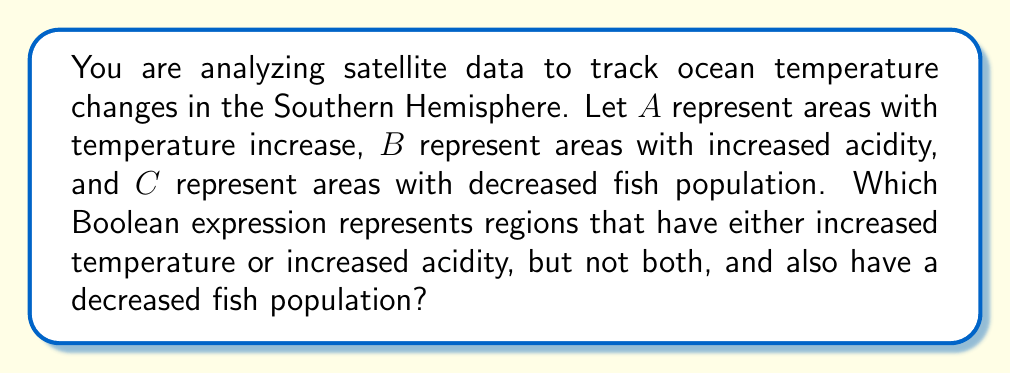Can you solve this math problem? Let's approach this step-by-step:

1) First, we need to identify the basic operation we're looking for. The phrase "either... or..., but not both" describes an exclusive OR operation, which is denoted by $\oplus$ in Boolean algebra.

2) So, for the first part of our condition (areas with either increased temperature or increased acidity, but not both), we can write: $A \oplus B$

3) The second part of our condition states that we also want areas with decreased fish population. This is represented by $C$.

4) We need both of these conditions to be true, which in Boolean algebra is represented by the AND operation ($\cdot$ or $\land$).

5) Therefore, our final expression will be: $(A \oplus B) \cdot C$

6) We can expand this using the definition of exclusive OR:
   $$(A \oplus B) \cdot C = ((A \lor B) \land (\lnot(A \land B))) \cdot C$$

7) This expression represents regions that have either increased temperature or increased acidity (but not both), and also have a decreased fish population.

This Boolean expression could be crucial for identifying areas of concern in your climate change research, particularly for studying the combined effects of temperature changes and acidification on marine life in the Southern Hemisphere.
Answer: $(A \oplus B) \cdot C$ 